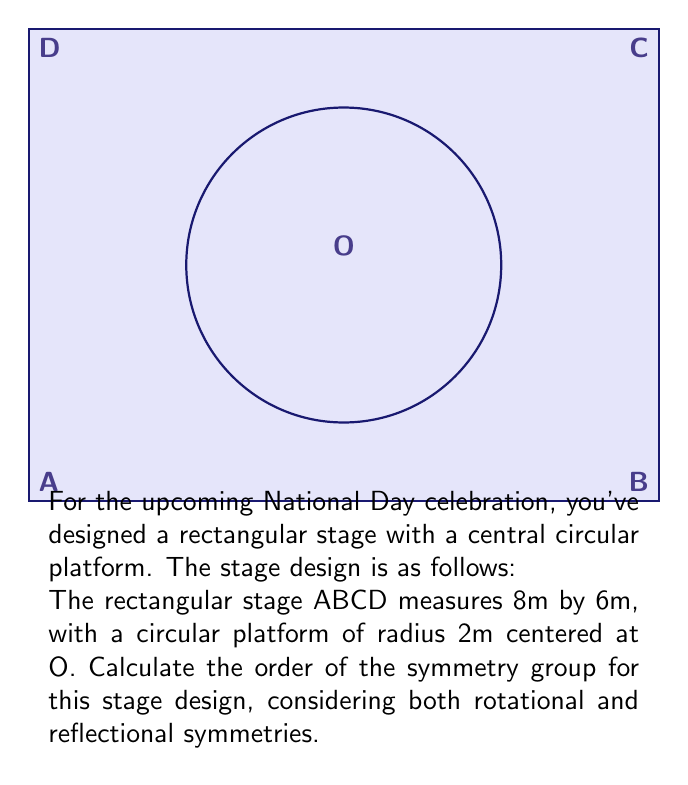Provide a solution to this math problem. To determine the symmetry group of the stage design, we need to consider both rotational and reflectional symmetries:

1) Rotational symmetries:
   - The design has 2-fold rotational symmetry (180° rotation) about the center O.
   - There are no other rotational symmetries.

2) Reflectional symmetries:
   - Vertical line of symmetry through the center O.
   - Horizontal line of symmetry through the center O.
   - Two diagonal lines of symmetry (from corner to corner).

3) Identity transformation (no change) is always a symmetry.

Let's count these symmetries:
   - 1 identity transformation
   - 1 180° rotation
   - 4 reflections (vertical, horizontal, and two diagonal)

Therefore, the total number of symmetries is 1 + 1 + 4 = 6.

The symmetry group of this design is isomorphic to the dihedral group $D_4$, which has order 8. However, since our rectangle is not square (8m by 6m), we don't have the 90° rotations, reducing the order to 6.

The resulting group is isomorphic to $D_3$, the symmetry group of an equilateral triangle, which also has 6 elements.
Answer: 6 